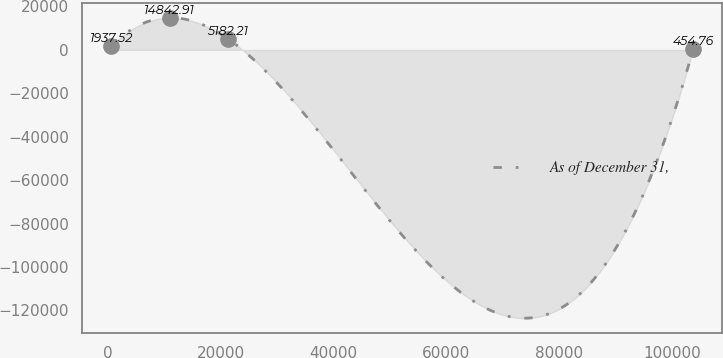<chart> <loc_0><loc_0><loc_500><loc_500><line_chart><ecel><fcel>As of December 31,<nl><fcel>545.83<fcel>1937.52<nl><fcel>10873.5<fcel>14842.9<nl><fcel>21201.1<fcel>5182.21<nl><fcel>103822<fcel>454.76<nl></chart> 